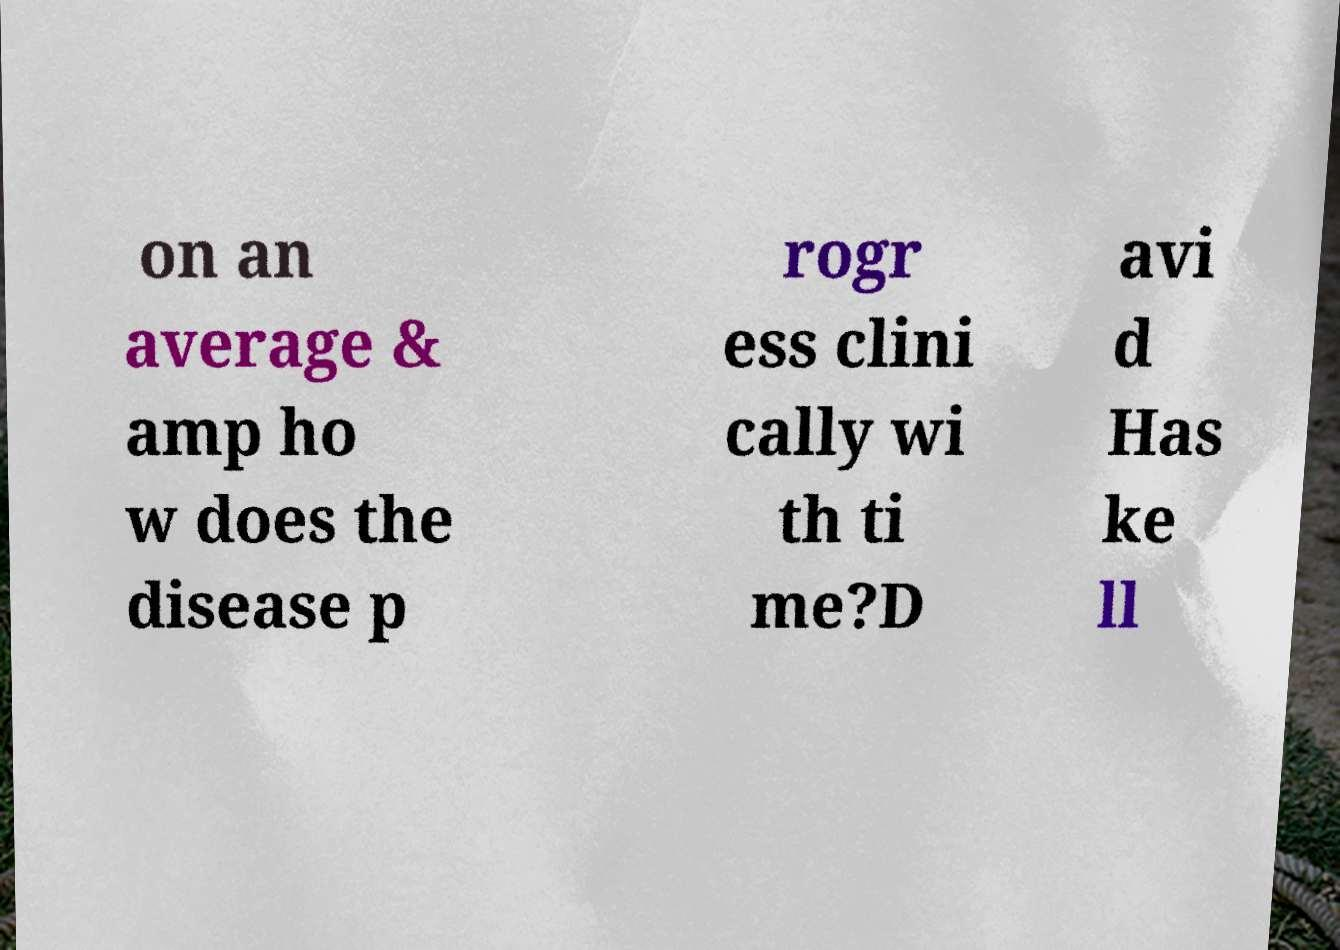Could you extract and type out the text from this image? on an average & amp ho w does the disease p rogr ess clini cally wi th ti me?D avi d Has ke ll 